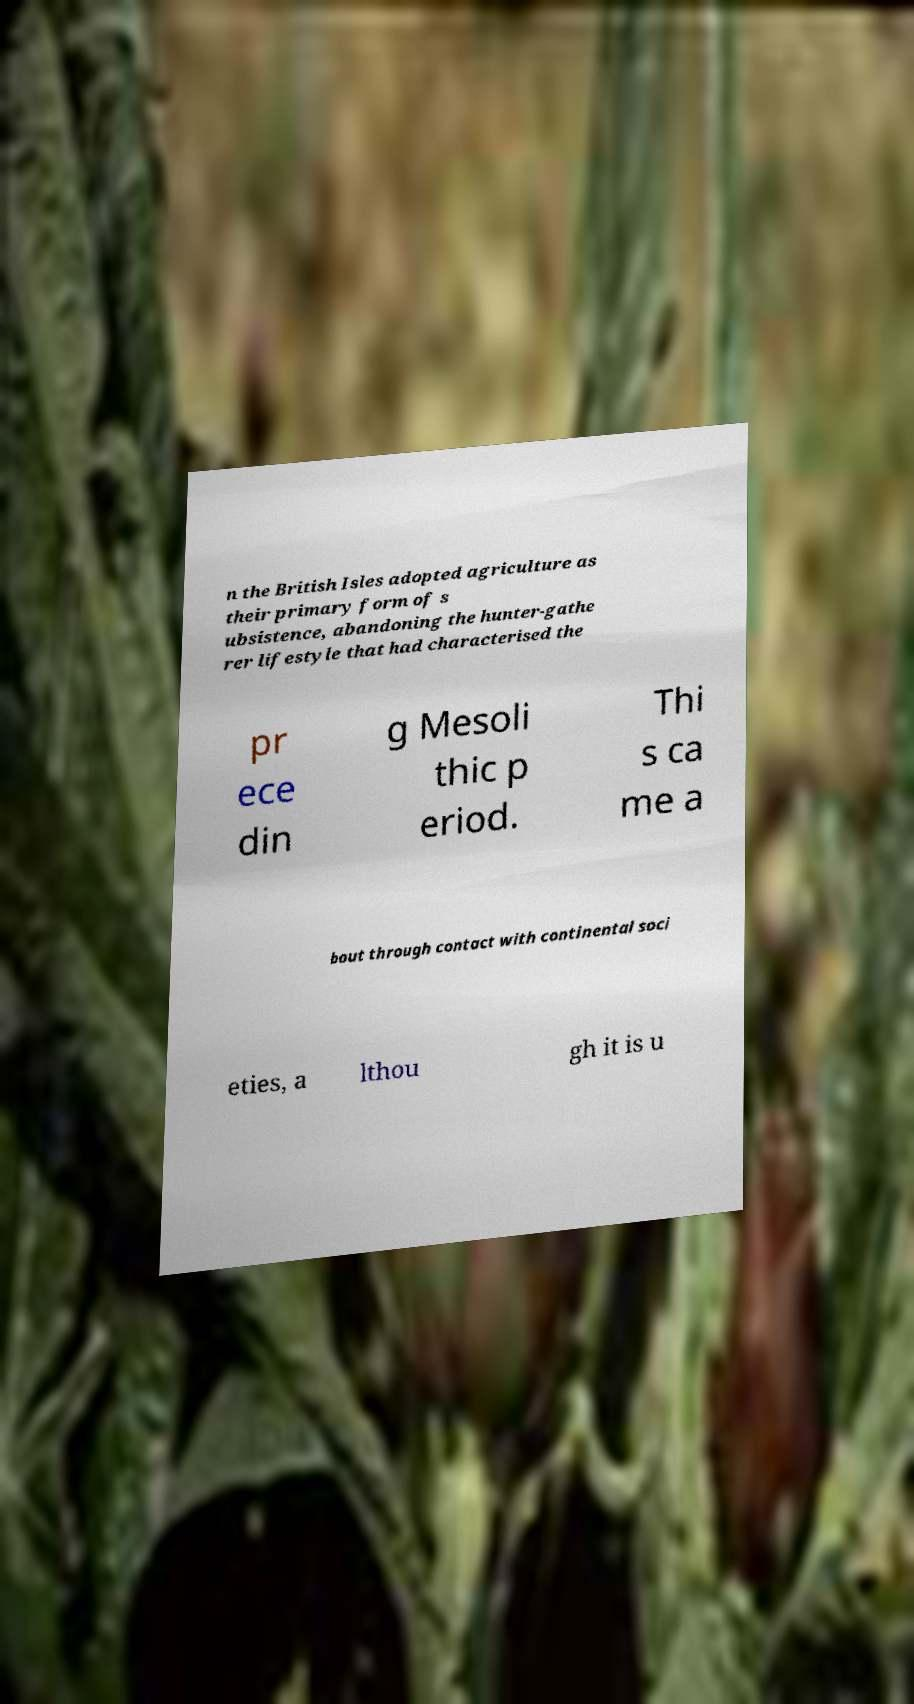Could you assist in decoding the text presented in this image and type it out clearly? n the British Isles adopted agriculture as their primary form of s ubsistence, abandoning the hunter-gathe rer lifestyle that had characterised the pr ece din g Mesoli thic p eriod. Thi s ca me a bout through contact with continental soci eties, a lthou gh it is u 